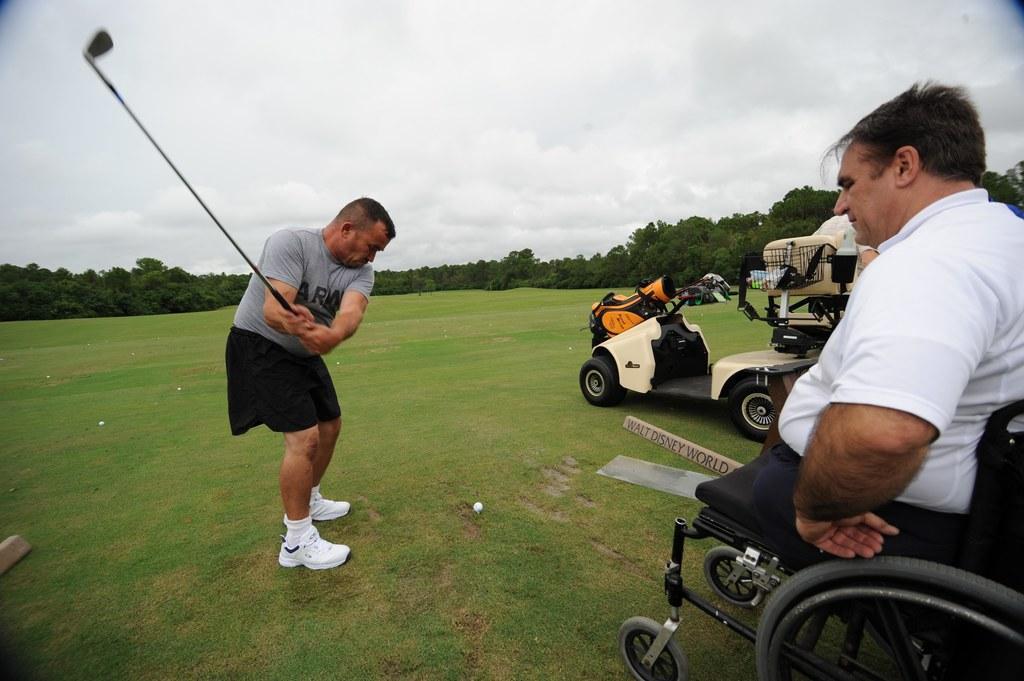Please provide a concise description of this image. This is the man standing and holding a golf bat in his hands. This looks like a golf ball, which is on the grass. On the right side of the image, I can see another person sitting on the wheelchair. I think these are the vehicles. I can the trees. This is the sky. 